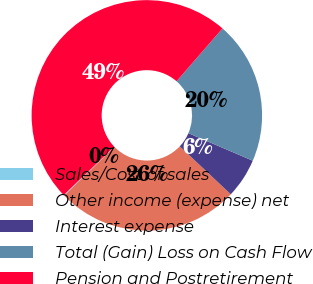Convert chart. <chart><loc_0><loc_0><loc_500><loc_500><pie_chart><fcel>Sales/Cost of sales<fcel>Other income (expense) net<fcel>Interest expense<fcel>Total (Gain) Loss on Cash Flow<fcel>Pension and Postretirement<nl><fcel>0.11%<fcel>25.72%<fcel>5.57%<fcel>20.04%<fcel>48.55%<nl></chart> 